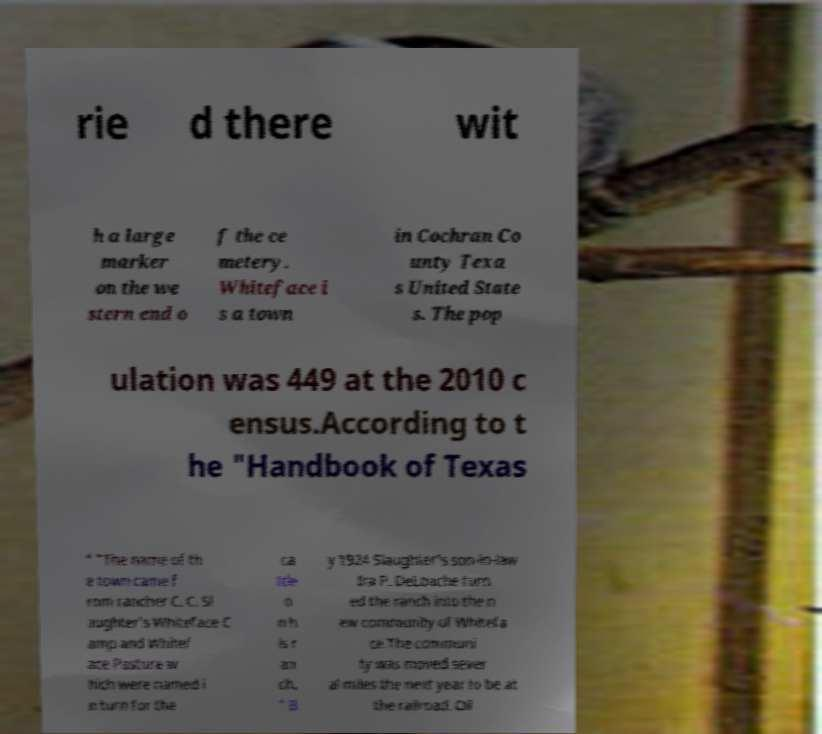There's text embedded in this image that I need extracted. Can you transcribe it verbatim? rie d there wit h a large marker on the we stern end o f the ce metery. Whiteface i s a town in Cochran Co unty Texa s United State s. The pop ulation was 449 at the 2010 c ensus.According to t he "Handbook of Texas " "The name of th e town came f rom rancher C. C. Sl aughter's Whiteface C amp and Whitef ace Pasture w hich were named i n turn for the ca ttle o n h is r an ch. " B y 1924 Slaughter's son-in-law Ira P. DeLoache turn ed the ranch into the n ew community of Whitefa ce.The communi ty was moved sever al miles the next year to be at the railroad. Oil 